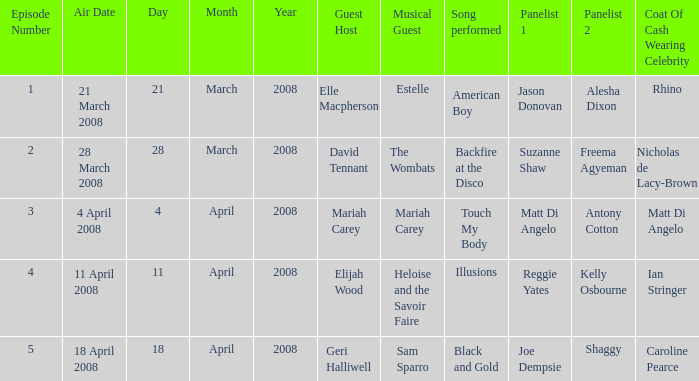Name the musical guest where guest host is elle macpherson Estelle ( American Boy ). 